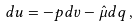<formula> <loc_0><loc_0><loc_500><loc_500>d u = - p d v - \hat { \mu } d q \, ,</formula> 